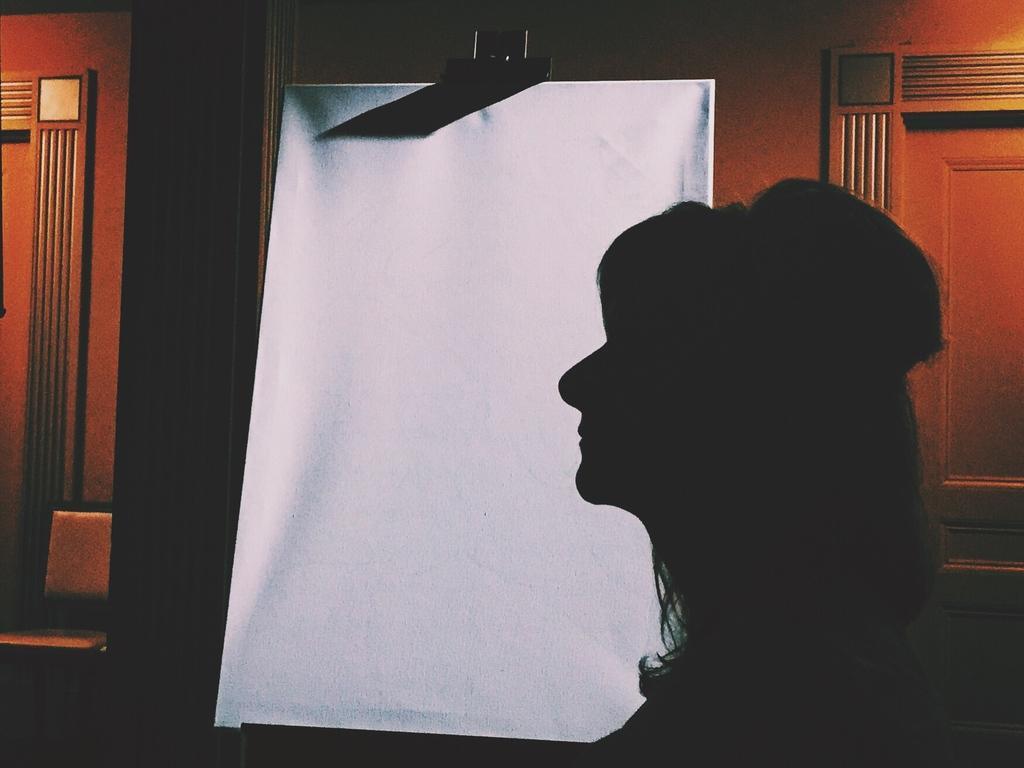How would you summarize this image in a sentence or two? In this image, I can see a person and a whiteboard. In the background, there is a wooden wall. 